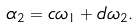<formula> <loc_0><loc_0><loc_500><loc_500>\alpha _ { 2 } = c \omega _ { 1 } + d \omega _ { 2 } .</formula> 